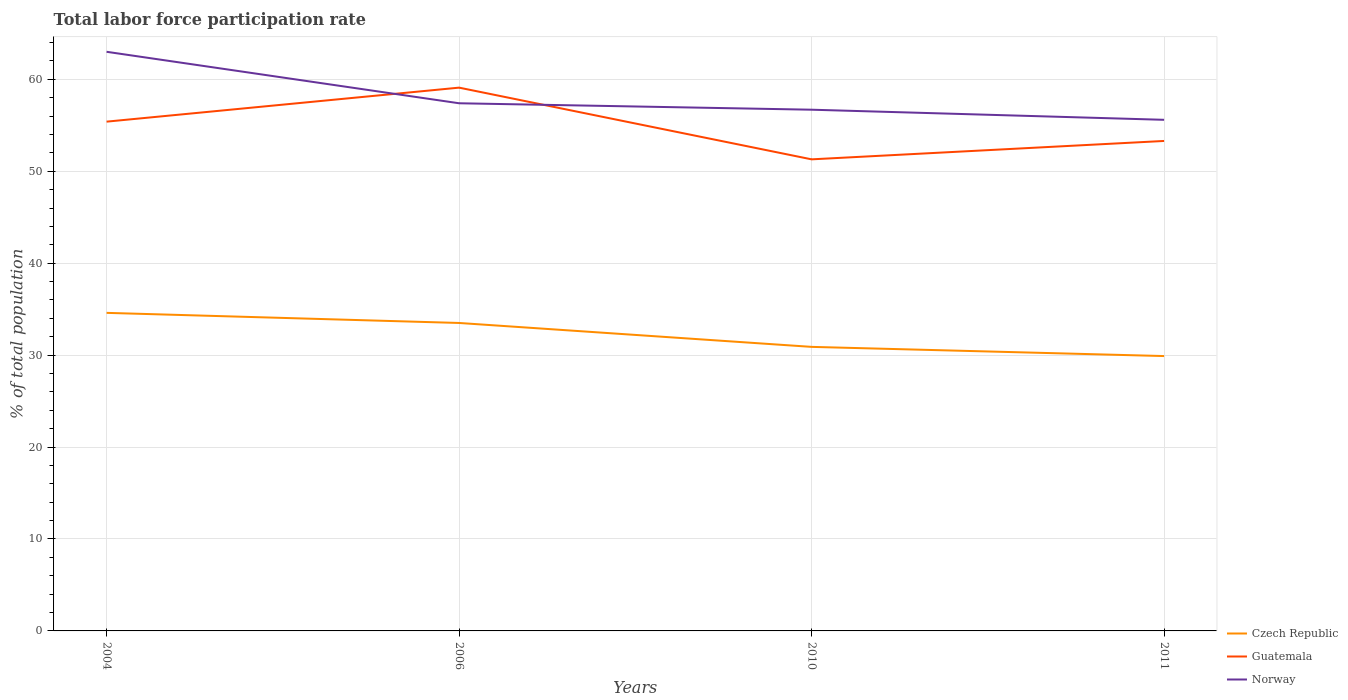How many different coloured lines are there?
Ensure brevity in your answer.  3. Does the line corresponding to Guatemala intersect with the line corresponding to Czech Republic?
Give a very brief answer. No. Is the number of lines equal to the number of legend labels?
Make the answer very short. Yes. Across all years, what is the maximum total labor force participation rate in Czech Republic?
Provide a succinct answer. 29.9. What is the total total labor force participation rate in Guatemala in the graph?
Make the answer very short. -2. What is the difference between the highest and the second highest total labor force participation rate in Guatemala?
Provide a succinct answer. 7.8. What is the difference between the highest and the lowest total labor force participation rate in Norway?
Your answer should be compact. 1. Is the total labor force participation rate in Norway strictly greater than the total labor force participation rate in Guatemala over the years?
Your answer should be very brief. No. How many lines are there?
Provide a short and direct response. 3. Are the values on the major ticks of Y-axis written in scientific E-notation?
Provide a short and direct response. No. Does the graph contain any zero values?
Ensure brevity in your answer.  No. Where does the legend appear in the graph?
Provide a short and direct response. Bottom right. What is the title of the graph?
Provide a short and direct response. Total labor force participation rate. What is the label or title of the Y-axis?
Provide a short and direct response. % of total population. What is the % of total population of Czech Republic in 2004?
Offer a terse response. 34.6. What is the % of total population in Guatemala in 2004?
Your response must be concise. 55.4. What is the % of total population in Norway in 2004?
Provide a succinct answer. 63. What is the % of total population in Czech Republic in 2006?
Give a very brief answer. 33.5. What is the % of total population of Guatemala in 2006?
Offer a very short reply. 59.1. What is the % of total population in Norway in 2006?
Provide a short and direct response. 57.4. What is the % of total population in Czech Republic in 2010?
Offer a terse response. 30.9. What is the % of total population of Guatemala in 2010?
Provide a short and direct response. 51.3. What is the % of total population of Norway in 2010?
Your answer should be compact. 56.7. What is the % of total population in Czech Republic in 2011?
Make the answer very short. 29.9. What is the % of total population in Guatemala in 2011?
Ensure brevity in your answer.  53.3. What is the % of total population of Norway in 2011?
Give a very brief answer. 55.6. Across all years, what is the maximum % of total population of Czech Republic?
Offer a very short reply. 34.6. Across all years, what is the maximum % of total population of Guatemala?
Give a very brief answer. 59.1. Across all years, what is the maximum % of total population in Norway?
Ensure brevity in your answer.  63. Across all years, what is the minimum % of total population of Czech Republic?
Provide a succinct answer. 29.9. Across all years, what is the minimum % of total population in Guatemala?
Offer a terse response. 51.3. Across all years, what is the minimum % of total population of Norway?
Your answer should be very brief. 55.6. What is the total % of total population in Czech Republic in the graph?
Ensure brevity in your answer.  128.9. What is the total % of total population in Guatemala in the graph?
Offer a very short reply. 219.1. What is the total % of total population in Norway in the graph?
Keep it short and to the point. 232.7. What is the difference between the % of total population of Norway in 2004 and that in 2006?
Provide a succinct answer. 5.6. What is the difference between the % of total population of Czech Republic in 2004 and that in 2010?
Keep it short and to the point. 3.7. What is the difference between the % of total population in Guatemala in 2004 and that in 2010?
Offer a terse response. 4.1. What is the difference between the % of total population of Czech Republic in 2004 and that in 2011?
Provide a succinct answer. 4.7. What is the difference between the % of total population of Guatemala in 2004 and that in 2011?
Offer a very short reply. 2.1. What is the difference between the % of total population in Norway in 2004 and that in 2011?
Provide a short and direct response. 7.4. What is the difference between the % of total population in Czech Republic in 2006 and that in 2010?
Your answer should be compact. 2.6. What is the difference between the % of total population in Guatemala in 2006 and that in 2010?
Ensure brevity in your answer.  7.8. What is the difference between the % of total population of Czech Republic in 2006 and that in 2011?
Your answer should be very brief. 3.6. What is the difference between the % of total population in Norway in 2006 and that in 2011?
Offer a terse response. 1.8. What is the difference between the % of total population in Czech Republic in 2010 and that in 2011?
Make the answer very short. 1. What is the difference between the % of total population in Guatemala in 2010 and that in 2011?
Provide a succinct answer. -2. What is the difference between the % of total population in Norway in 2010 and that in 2011?
Your answer should be compact. 1.1. What is the difference between the % of total population of Czech Republic in 2004 and the % of total population of Guatemala in 2006?
Make the answer very short. -24.5. What is the difference between the % of total population of Czech Republic in 2004 and the % of total population of Norway in 2006?
Keep it short and to the point. -22.8. What is the difference between the % of total population of Guatemala in 2004 and the % of total population of Norway in 2006?
Offer a terse response. -2. What is the difference between the % of total population of Czech Republic in 2004 and the % of total population of Guatemala in 2010?
Your answer should be very brief. -16.7. What is the difference between the % of total population of Czech Republic in 2004 and the % of total population of Norway in 2010?
Your answer should be compact. -22.1. What is the difference between the % of total population of Guatemala in 2004 and the % of total population of Norway in 2010?
Keep it short and to the point. -1.3. What is the difference between the % of total population in Czech Republic in 2004 and the % of total population in Guatemala in 2011?
Provide a short and direct response. -18.7. What is the difference between the % of total population of Czech Republic in 2004 and the % of total population of Norway in 2011?
Offer a terse response. -21. What is the difference between the % of total population of Guatemala in 2004 and the % of total population of Norway in 2011?
Keep it short and to the point. -0.2. What is the difference between the % of total population in Czech Republic in 2006 and the % of total population in Guatemala in 2010?
Your answer should be very brief. -17.8. What is the difference between the % of total population in Czech Republic in 2006 and the % of total population in Norway in 2010?
Your response must be concise. -23.2. What is the difference between the % of total population of Czech Republic in 2006 and the % of total population of Guatemala in 2011?
Provide a short and direct response. -19.8. What is the difference between the % of total population of Czech Republic in 2006 and the % of total population of Norway in 2011?
Ensure brevity in your answer.  -22.1. What is the difference between the % of total population of Czech Republic in 2010 and the % of total population of Guatemala in 2011?
Make the answer very short. -22.4. What is the difference between the % of total population of Czech Republic in 2010 and the % of total population of Norway in 2011?
Your answer should be compact. -24.7. What is the average % of total population of Czech Republic per year?
Give a very brief answer. 32.23. What is the average % of total population in Guatemala per year?
Your answer should be very brief. 54.77. What is the average % of total population of Norway per year?
Offer a terse response. 58.17. In the year 2004, what is the difference between the % of total population of Czech Republic and % of total population of Guatemala?
Ensure brevity in your answer.  -20.8. In the year 2004, what is the difference between the % of total population of Czech Republic and % of total population of Norway?
Make the answer very short. -28.4. In the year 2004, what is the difference between the % of total population in Guatemala and % of total population in Norway?
Keep it short and to the point. -7.6. In the year 2006, what is the difference between the % of total population of Czech Republic and % of total population of Guatemala?
Keep it short and to the point. -25.6. In the year 2006, what is the difference between the % of total population of Czech Republic and % of total population of Norway?
Ensure brevity in your answer.  -23.9. In the year 2010, what is the difference between the % of total population in Czech Republic and % of total population in Guatemala?
Offer a terse response. -20.4. In the year 2010, what is the difference between the % of total population of Czech Republic and % of total population of Norway?
Your response must be concise. -25.8. In the year 2011, what is the difference between the % of total population in Czech Republic and % of total population in Guatemala?
Give a very brief answer. -23.4. In the year 2011, what is the difference between the % of total population in Czech Republic and % of total population in Norway?
Offer a very short reply. -25.7. What is the ratio of the % of total population in Czech Republic in 2004 to that in 2006?
Offer a terse response. 1.03. What is the ratio of the % of total population in Guatemala in 2004 to that in 2006?
Provide a succinct answer. 0.94. What is the ratio of the % of total population of Norway in 2004 to that in 2006?
Your answer should be compact. 1.1. What is the ratio of the % of total population in Czech Republic in 2004 to that in 2010?
Offer a terse response. 1.12. What is the ratio of the % of total population in Guatemala in 2004 to that in 2010?
Ensure brevity in your answer.  1.08. What is the ratio of the % of total population of Norway in 2004 to that in 2010?
Make the answer very short. 1.11. What is the ratio of the % of total population of Czech Republic in 2004 to that in 2011?
Keep it short and to the point. 1.16. What is the ratio of the % of total population of Guatemala in 2004 to that in 2011?
Offer a very short reply. 1.04. What is the ratio of the % of total population in Norway in 2004 to that in 2011?
Ensure brevity in your answer.  1.13. What is the ratio of the % of total population in Czech Republic in 2006 to that in 2010?
Your response must be concise. 1.08. What is the ratio of the % of total population of Guatemala in 2006 to that in 2010?
Offer a very short reply. 1.15. What is the ratio of the % of total population of Norway in 2006 to that in 2010?
Keep it short and to the point. 1.01. What is the ratio of the % of total population of Czech Republic in 2006 to that in 2011?
Offer a very short reply. 1.12. What is the ratio of the % of total population in Guatemala in 2006 to that in 2011?
Your response must be concise. 1.11. What is the ratio of the % of total population of Norway in 2006 to that in 2011?
Offer a very short reply. 1.03. What is the ratio of the % of total population of Czech Republic in 2010 to that in 2011?
Your answer should be very brief. 1.03. What is the ratio of the % of total population in Guatemala in 2010 to that in 2011?
Give a very brief answer. 0.96. What is the ratio of the % of total population in Norway in 2010 to that in 2011?
Your answer should be very brief. 1.02. What is the difference between the highest and the second highest % of total population of Czech Republic?
Keep it short and to the point. 1.1. What is the difference between the highest and the second highest % of total population in Guatemala?
Give a very brief answer. 3.7. What is the difference between the highest and the second highest % of total population of Norway?
Keep it short and to the point. 5.6. What is the difference between the highest and the lowest % of total population in Czech Republic?
Ensure brevity in your answer.  4.7. 